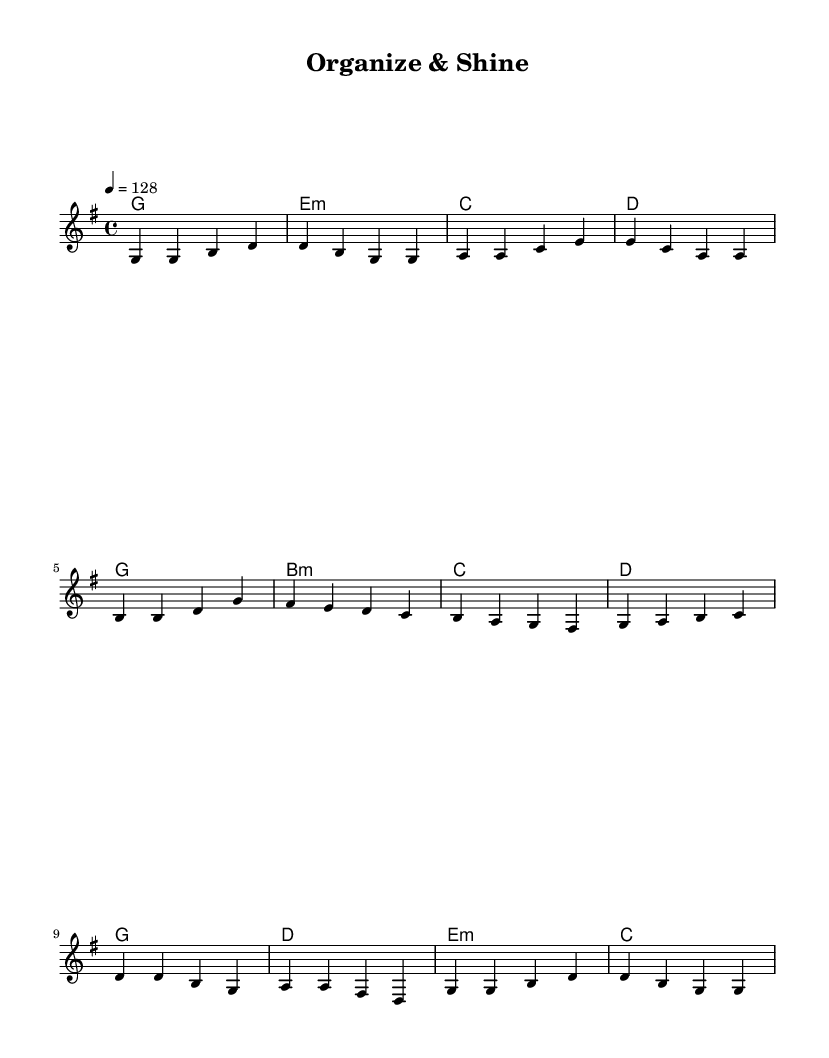What is the key signature of this music? The key signature is G major, which has one sharp (F#).
Answer: G major What is the time signature of this piece? The time signature displayed is 4/4, which means there are four beats in each measure.
Answer: 4/4 What is the tempo marking for this piece? The tempo marking indicates a speed of 128 beats per minute.
Answer: 128 How many measures are in the verse section? The verse contains four measures as indicated by the structure of the melody and its repeats.
Answer: 4 In the chorus, what is the last chord played? The last chord of the chorus is G major, as shown in the chord progression.
Answer: G What is the theme of this K-Pop song? The theme centers around productivity and workplace organization, as described in the lyrics.
Answer: Productivity How many times does the phrase "organize and shine" appear in the chorus? The phrase "organize and shine" appears once in the chorus.
Answer: Once 